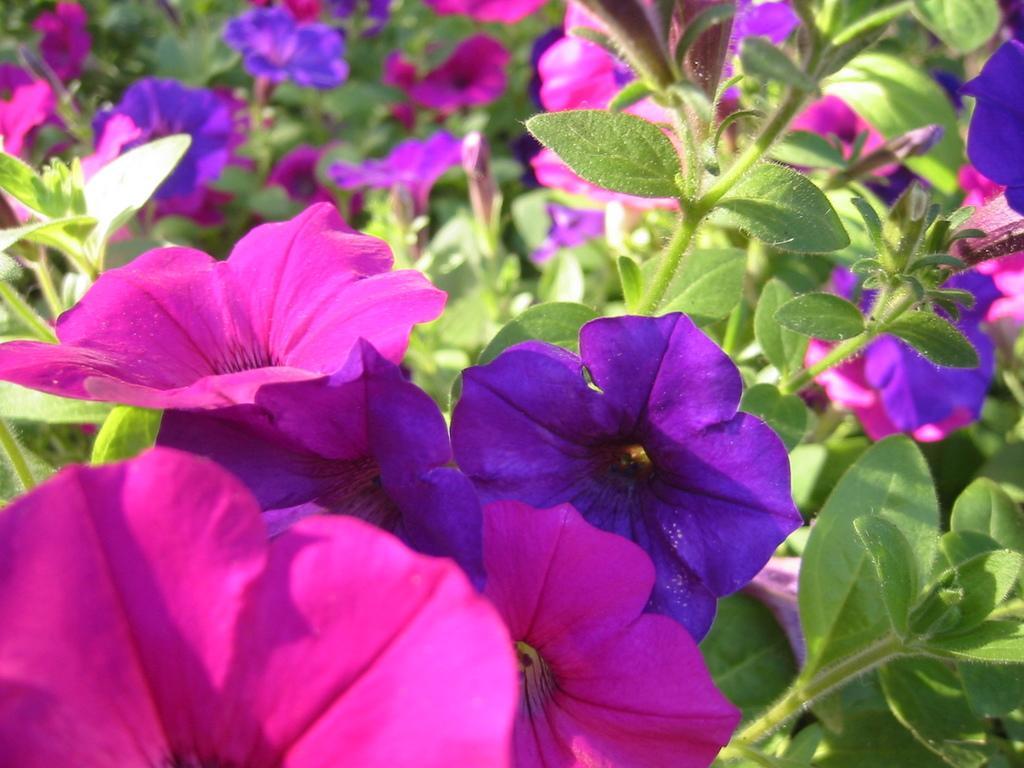Describe this image in one or two sentences. This image is taken outdoors. In this image there are many plants with beautiful flowers. Those flowers are purple and pink in colour. 